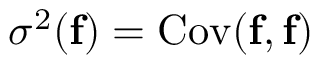<formula> <loc_0><loc_0><loc_500><loc_500>\sigma ^ { 2 } ( f ) = C o v ( f , f )</formula> 